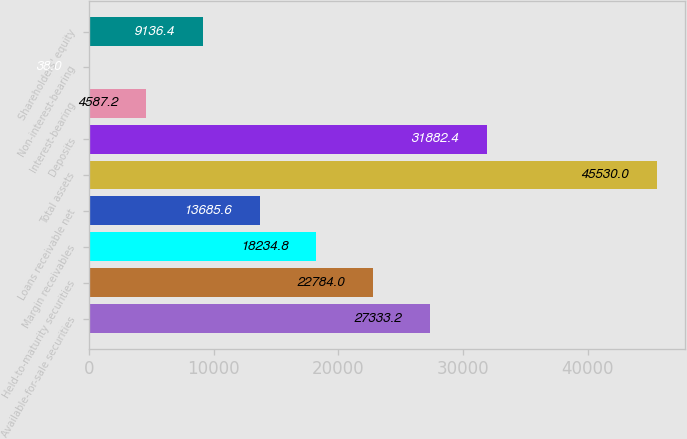Convert chart. <chart><loc_0><loc_0><loc_500><loc_500><bar_chart><fcel>Available-for-sale securities<fcel>Held-to-maturity securities<fcel>Margin receivables<fcel>Loans receivable net<fcel>Total assets<fcel>Deposits<fcel>Interest-bearing<fcel>Non-interest-bearing<fcel>Shareholders' equity<nl><fcel>27333.2<fcel>22784<fcel>18234.8<fcel>13685.6<fcel>45530<fcel>31882.4<fcel>4587.2<fcel>38<fcel>9136.4<nl></chart> 